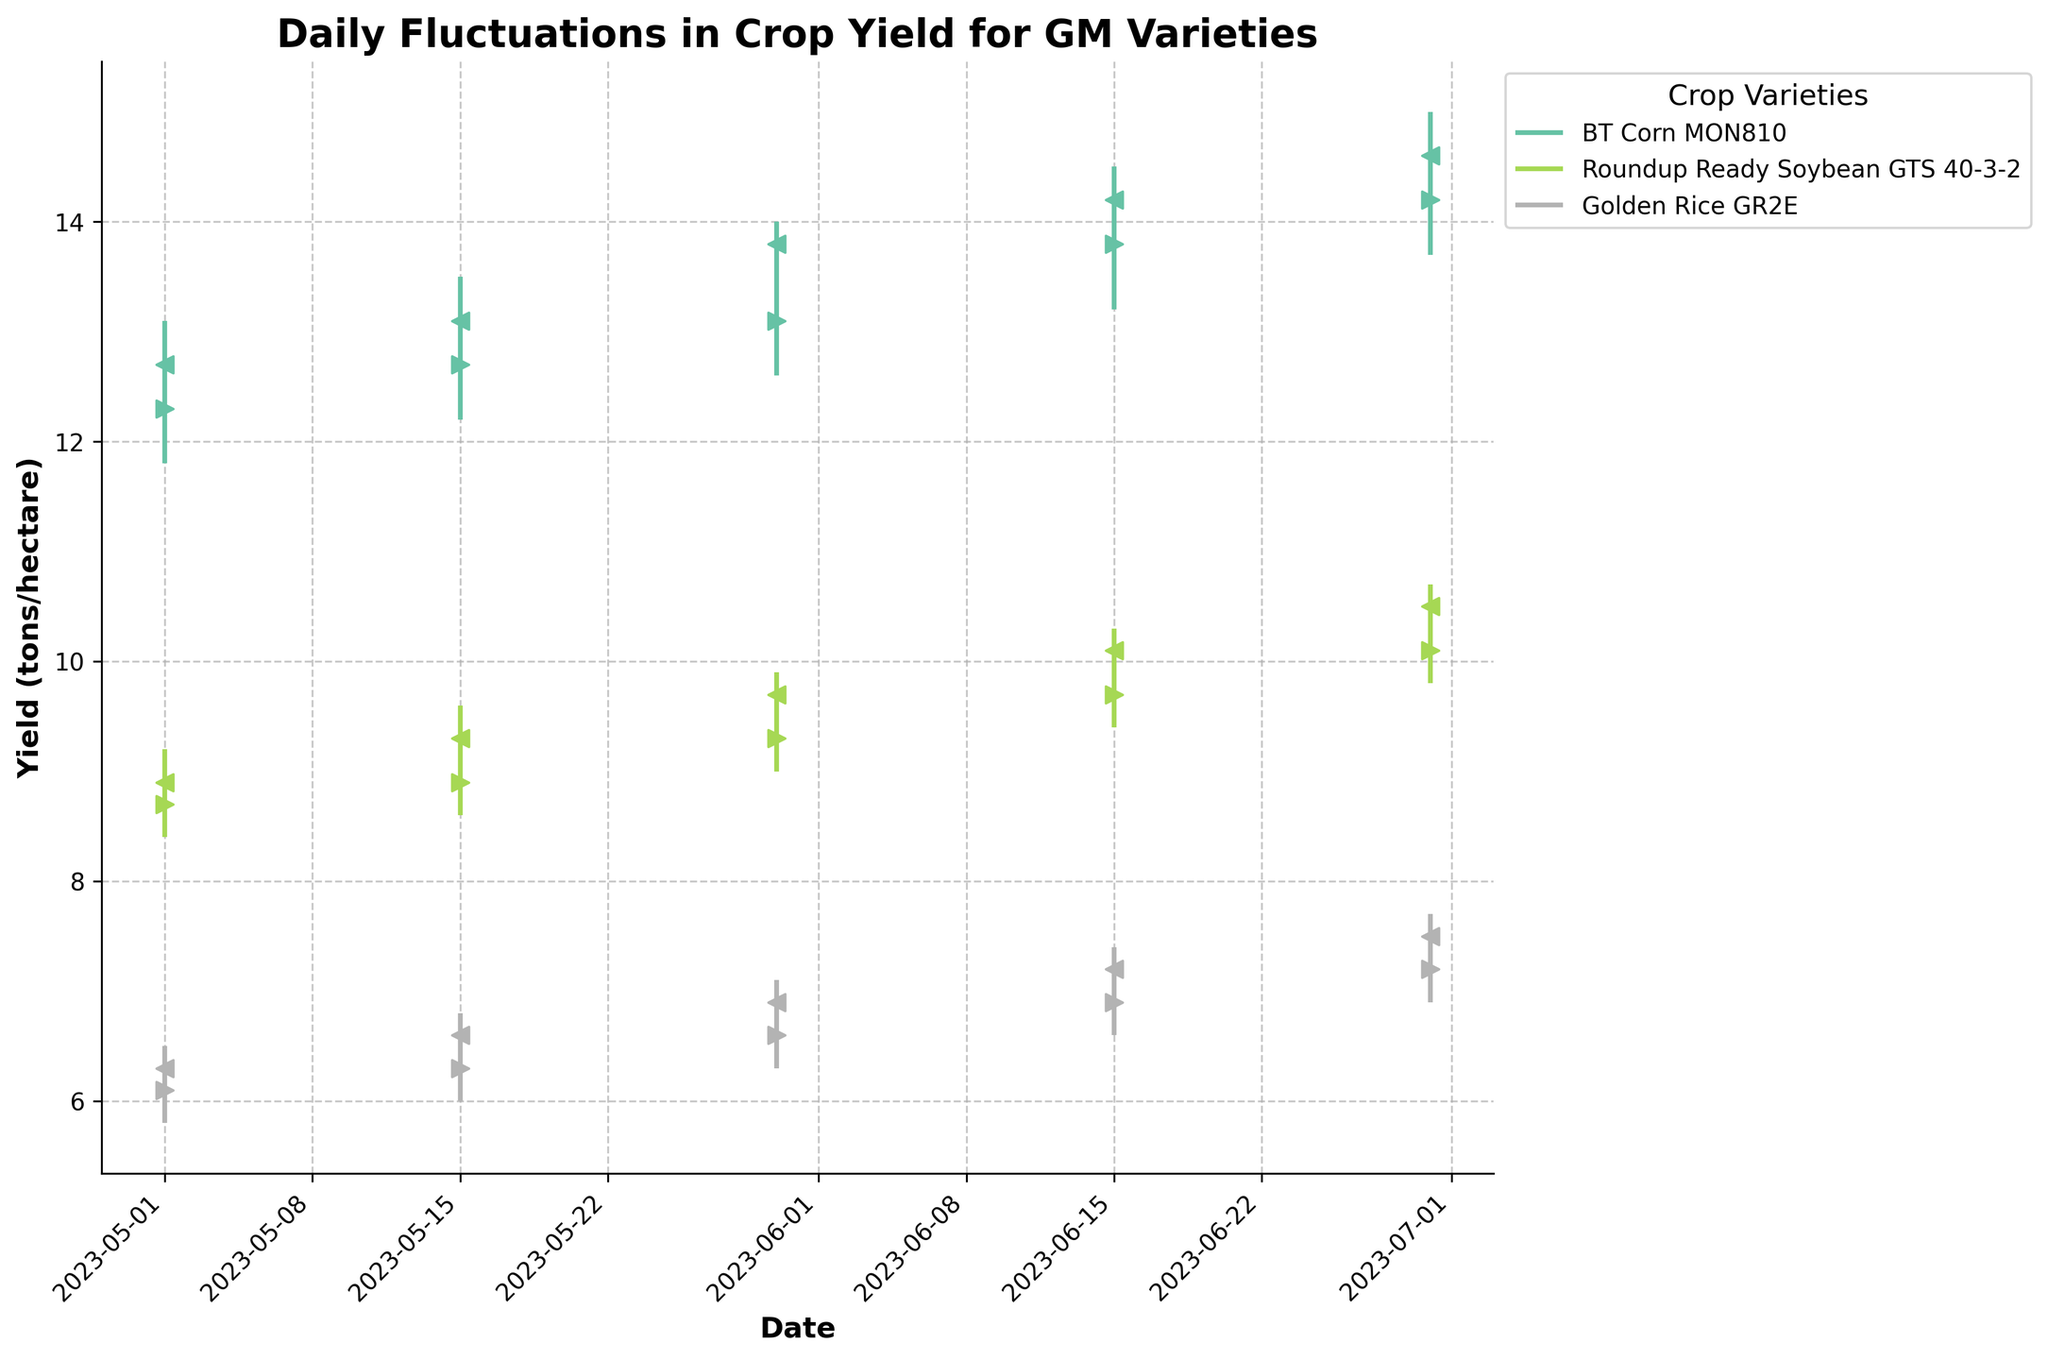What is the title of the chart? The title of the chart is located at the top and reads 'Daily Fluctuations in Crop Yield for GM Varieties'.
Answer: Daily Fluctuations in Crop Yield for GM Varieties Which crop variety had the highest yield on June 15th? On June 15th, the crop variety with the highest yield can be determined by looking at the "High" point for each crop. BT Corn MON810 had the highest yield at 14.5.
Answer: BT Corn MON810 What were the opening and closing yields for Roundup Ready Soybean GTS 40-3-2 on May 15th? By referring to May 15th data for Roundup Ready Soybean GTS 40-3-2, the opening yield is marked with a ">" and the closing yield with a "<". The values are 8.9 and 9.3, respectively.
Answer: 8.9, 9.3 How much did the yield of Golden Rice GR2E increase from June 15th to June 30th? To find the increase, subtract the closing yield on June 15th from the closing yield on June 30th. The values are 7.5 and 7.2. Therefore, 7.5 - 7.2 = 0.3.
Answer: 0.3 Compare the yield fluctuation ranges between BT Corn MON810 and Golden Rice GR2E on June 30th. Which had a greater range? To determine the fluctuation range, subtract the low yield from the high yield for each crop on June 30th. BT Corn MON810 has a range of 15.0 - 13.7 = 1.3, and Golden Rice GR2E has a range of 7.7 - 6.9 = 0.8. BT Corn MON810 had a greater range.
Answer: BT Corn MON810 Which crop showed the most consistent closing yield increase over the period shown? By examining the closing yields across the dates for each crop: BT Corn MON810's closing yields were 12.7, 13.1, 13.8, 14.2, 14.6 showing consistent increments.
Answer: BT Corn MON810 How did the opening yield of Roundup Ready Soybean GTS 40-3-2 on May 1st compare to its closing yield on the same date? Comparing the opening and closing yields of Roundup Ready Soybean GTS 40-3-2 on May 1st, the opening yield was 8.7 and the closing yield was 8.9. The closing yield was higher by 0.2.
Answer: Closing yield was higher by 0.2 What is the total increase in the closing yield of BT Corn MON810 from May 1st to June 30th? Compute the increase by subtracting the starting closing yield from the ending closing yield. The values are 14.6 and 12.7. Therefore, 14.6 - 12.7 = 1.9.
Answer: 1.9 Which crop variety had the lowest yield on May 30th? On May 30th, looking at the "Low" yield data, Golden Rice GR2E had the lowest yield at 6.3.
Answer: Golden Rice GR2E What is the average closing yield of Golden Rice GR2E across all dates? Add the closing yields on all dates and divide by the number of dates. The values are 6.3, 6.6, 6.9, 7.2, 7.5. The total is 34.5, so the average is 34.5/5 = 6.9.
Answer: 6.9 